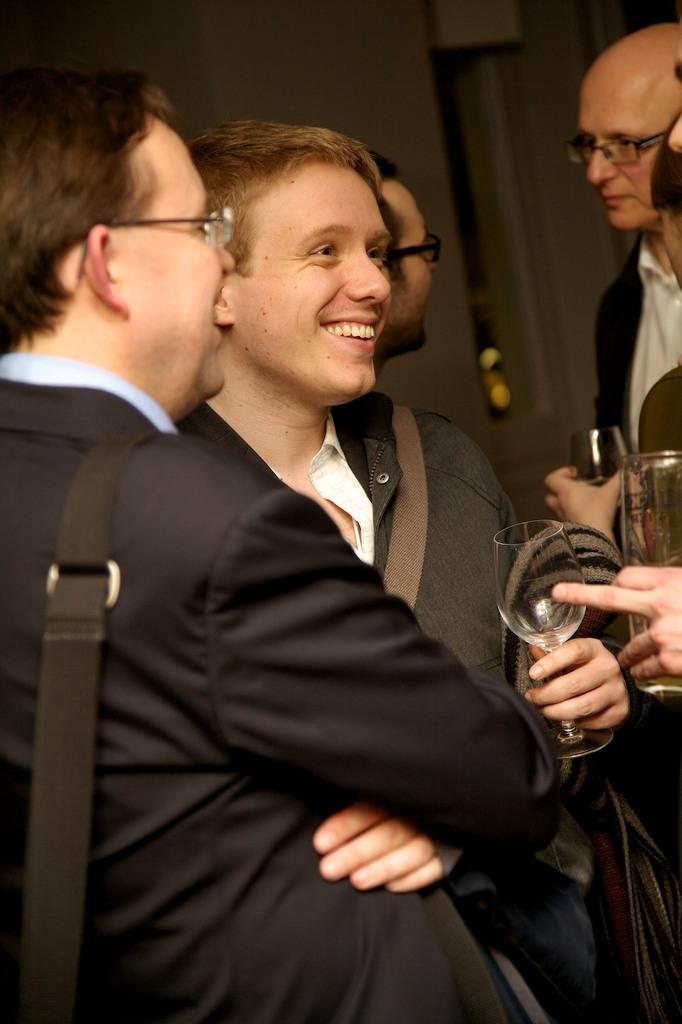What is the main subject of the image? The main subject of the image is a group of people. What are some of the people in the group holding? Some people in the group are holding glasses. What can be seen behind the group of people? There is a wall visible behind the people. What type of food is being served with the spoons in the image? There is no spoons present in the image, so it cannot be determined what type of food might be served with them. 